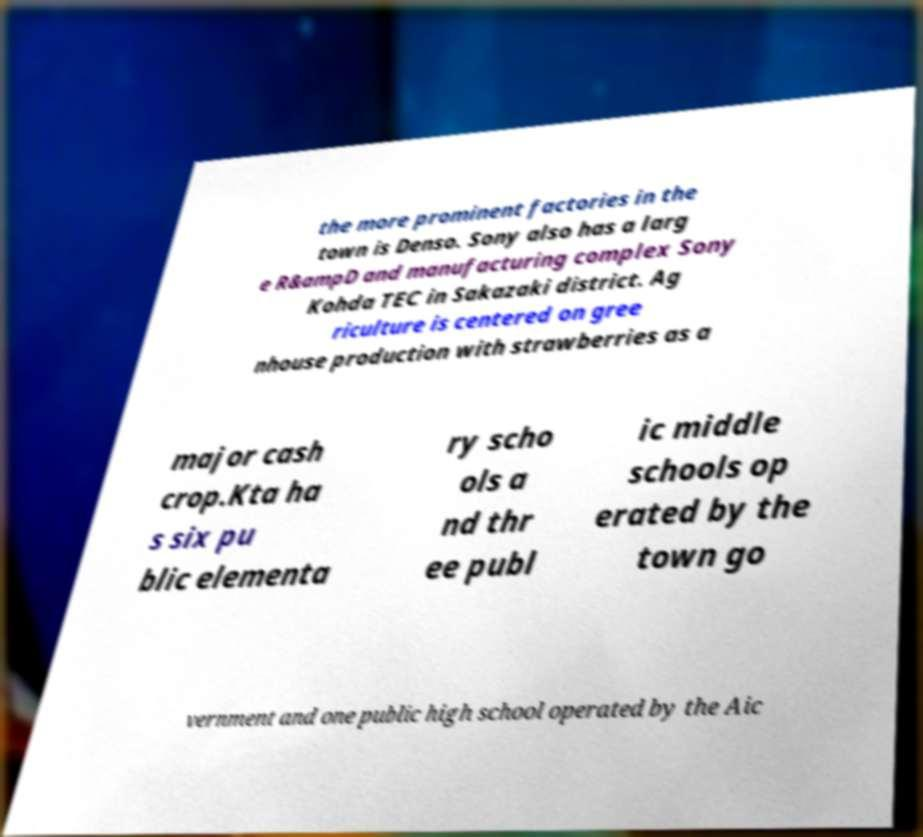I need the written content from this picture converted into text. Can you do that? the more prominent factories in the town is Denso. Sony also has a larg e R&ampD and manufacturing complex Sony Kohda TEC in Sakazaki district. Ag riculture is centered on gree nhouse production with strawberries as a major cash crop.Kta ha s six pu blic elementa ry scho ols a nd thr ee publ ic middle schools op erated by the town go vernment and one public high school operated by the Aic 